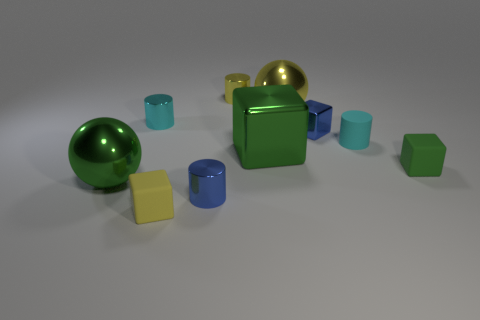Does the reflective quality of the objects in the image indicate anything about the material they are made of? Yes, the reflective quality you see in the image offers clues about the materials. Objects with a high-gloss, reflective surface typically suggest that they are made of materials like polished metal or glass, which have smooth surfaces that reflect light clearly. In contrast, the objects with a matte finish indicate that they could be composed of something more diffuse such as plastic or rubber which scatters the light, giving it a duller appearance. 